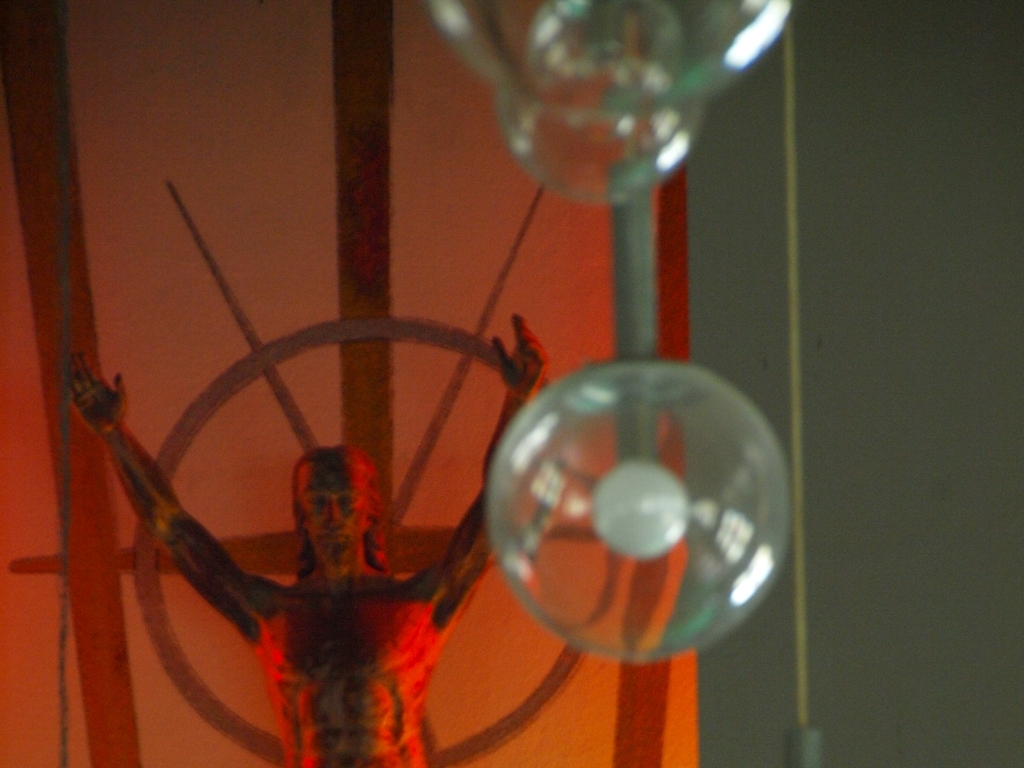What is the quality of the sculpture contour? The sculpture exhibits a distinct and purposefully rough contour, providing a textured and dramatic appearance that creates a striking visual effect. The contours are not smooth, but rather, they seem to emphasize a raw, almost unfinished quality that may suggest a deeper intent or symbolism behind the piece. 